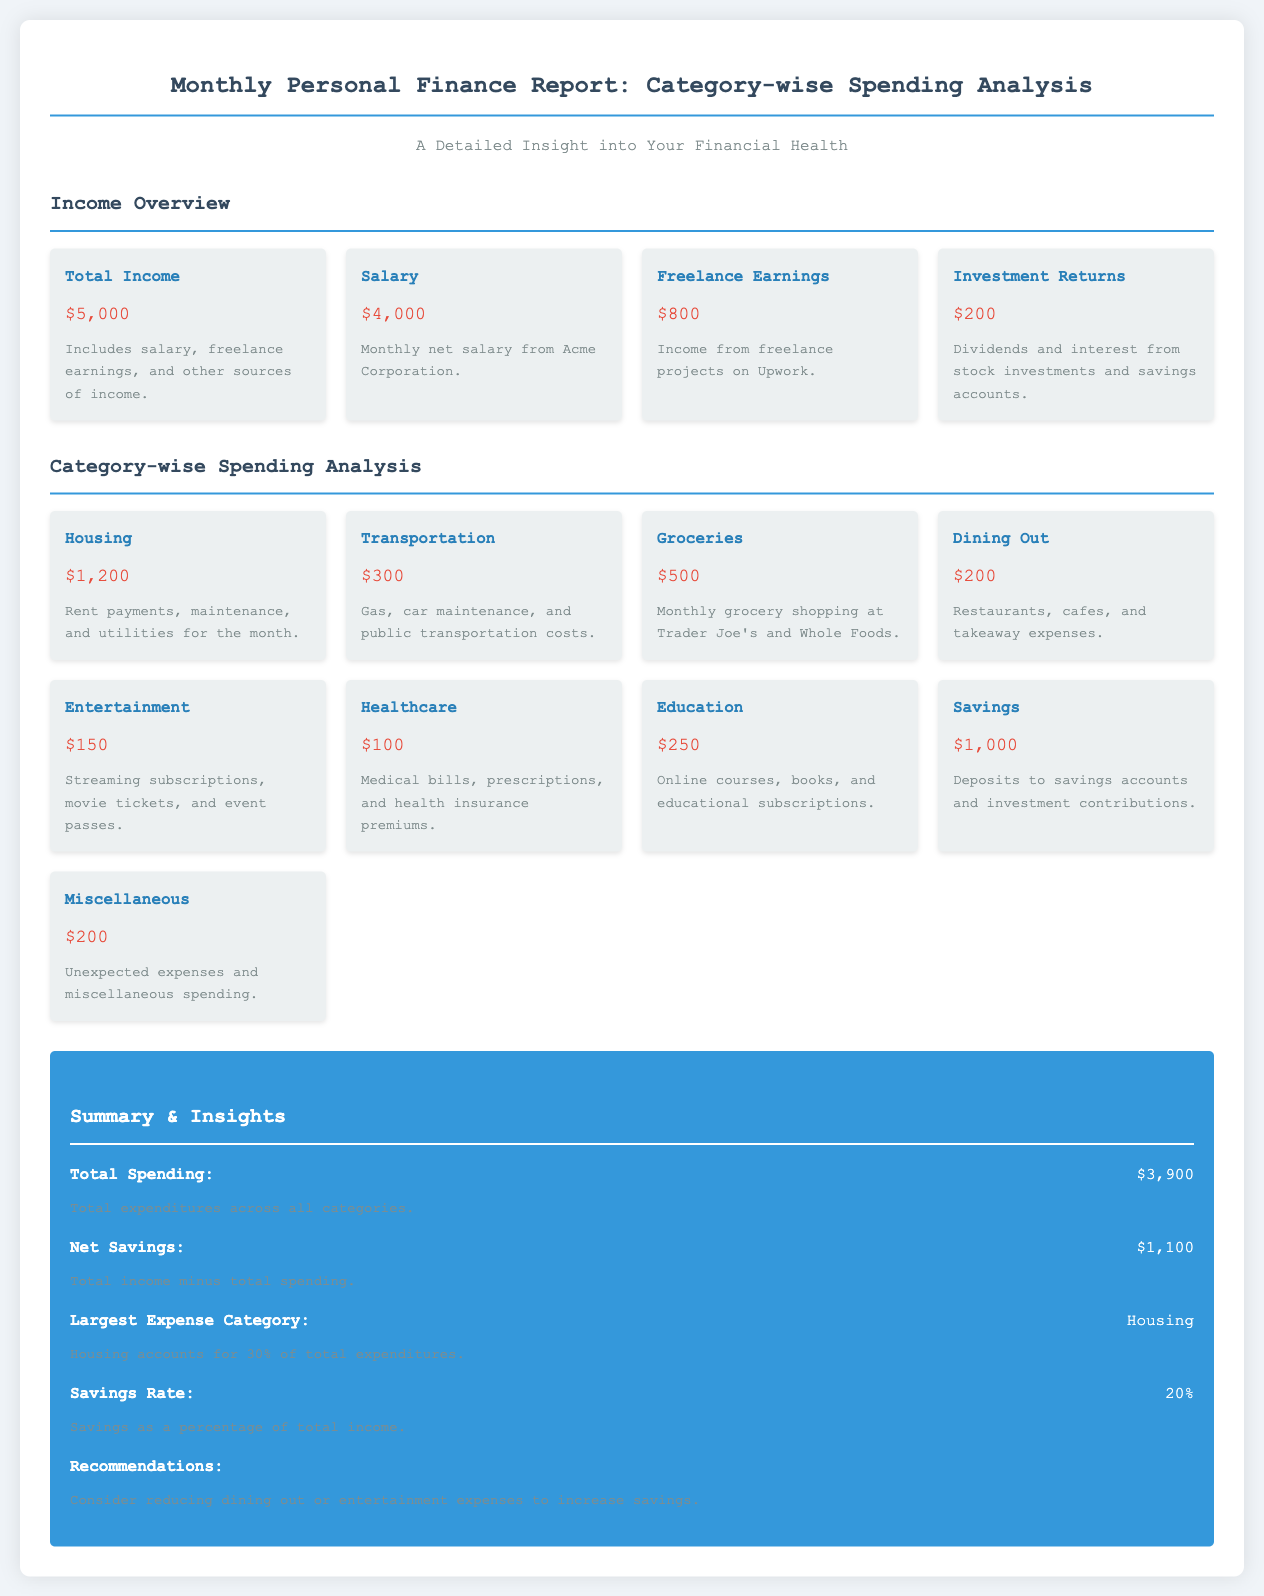What is the total income? The total income is listed at the top of the income overview section, which combines all sources of income.
Answer: $5,000 What is the largest expense category? The largest expense category is mentioned in the summary section, indicating the category with the highest spending.
Answer: Housing How much was spent on groceries? The amount spent on groceries is specified in the category-wise spending analysis section.
Answer: $500 What is the savings rate? The savings rate is provided in the summary & insights section, calculated as a percentage of total income.
Answer: 20% What is the total spending? The total spending is clearly stated in the summary section, calculated across all expenditure categories.
Answer: $3,900 How much did the healthcare cost? The cost related to healthcare is detailed in the category-wise spending analysis section.
Answer: $100 What is the amount for dining out? The amount spent on dining out can be found in the category-wise spending analysis section.
Answer: $200 What is the net savings? The net savings are indicated in the summary & insights section, calculated as total income minus total spending.
Answer: $1,100 How much was allocated to savings? The amount allocated to savings is listed under the category-wise spending analysis section.
Answer: $1,000 What was the spending on transportation? The spending on transportation is mentioned in the category-wise spending analysis section.
Answer: $300 